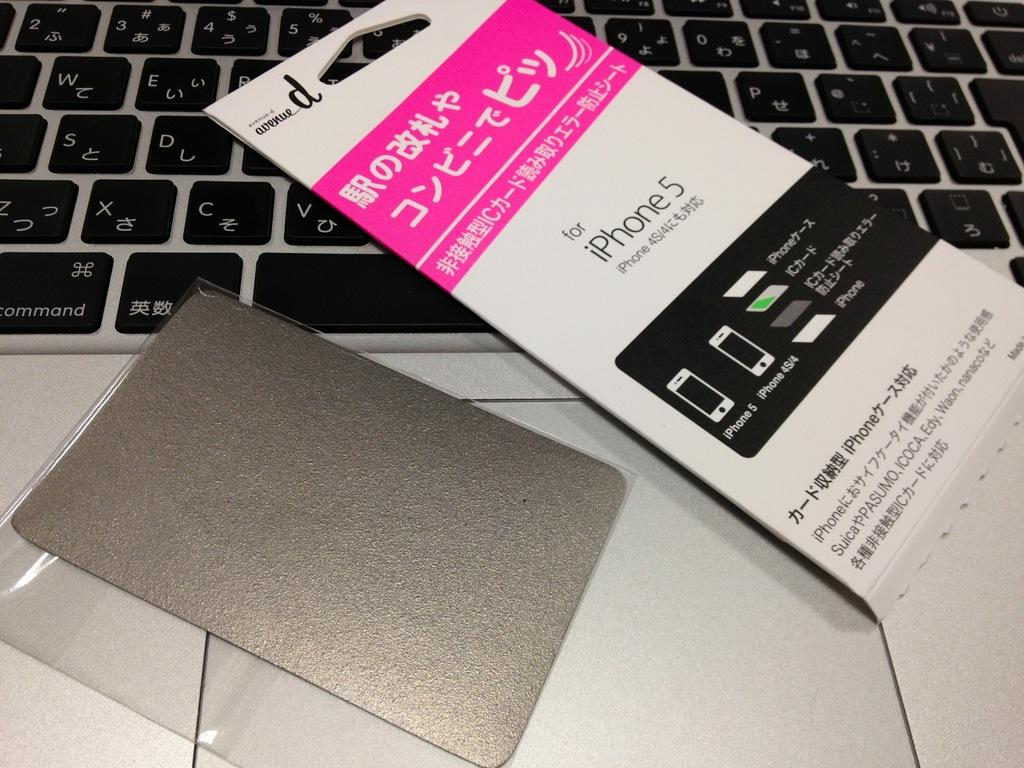<image>
Describe the image concisely. An iphone 5 screen protector in Japanese sitting on top of a Mac Book. 